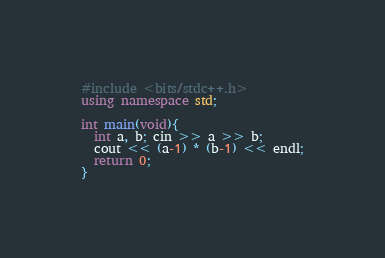<code> <loc_0><loc_0><loc_500><loc_500><_C++_>#include <bits/stdc++.h>
using namespace std;

int main(void){
  int a, b; cin >> a >> b;
  cout << (a-1) * (b-1) << endl;
  return 0;
}
</code> 